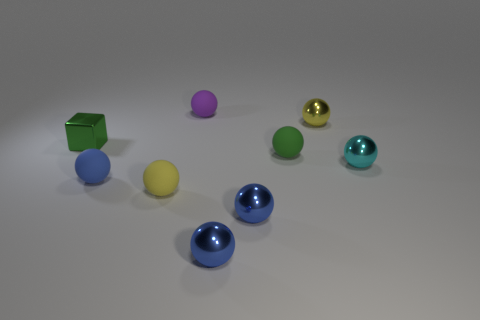Is there a blue shiny sphere behind the tiny green object in front of the cube?
Offer a very short reply. No. What number of small spheres are in front of the cyan object?
Keep it short and to the point. 4. Does the small yellow object that is right of the small yellow matte thing have the same material as the yellow object in front of the cube?
Your response must be concise. No. There is a small cube; is it the same color as the tiny metal sphere that is behind the small cyan metal thing?
Offer a terse response. No. What is the shape of the object that is both behind the green block and in front of the purple matte thing?
Ensure brevity in your answer.  Sphere. What number of small green matte cylinders are there?
Your answer should be compact. 0. There is a small object that is the same color as the block; what shape is it?
Provide a short and direct response. Sphere. What size is the yellow metal thing that is the same shape as the small cyan shiny object?
Make the answer very short. Small. Is the shape of the yellow thing that is in front of the small green metallic thing the same as  the small purple matte thing?
Offer a terse response. Yes. There is a tiny metal thing that is behind the green cube; what color is it?
Provide a short and direct response. Yellow. 